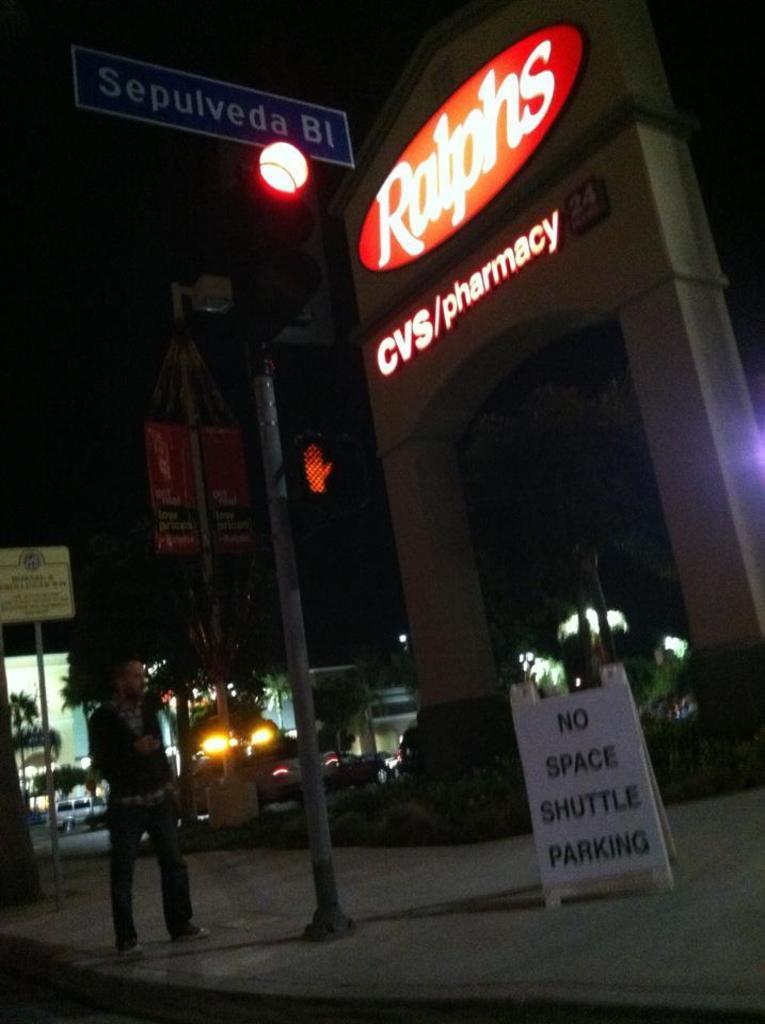Could you give a brief overview of what you see in this image? In this picture we can see a person on the road, here we can see a traffic signal, boards, trees, vehicles and some objects and in the background we can see it is dark. 